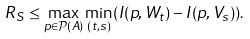<formula> <loc_0><loc_0><loc_500><loc_500>R _ { S } \leq \max _ { p \in \mathcal { P } ( A ) } \min _ { ( t , s ) } ( I ( p , W _ { t } ) - I ( p , V _ { s } ) ) .</formula> 